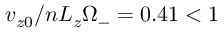Convert formula to latex. <formula><loc_0><loc_0><loc_500><loc_500>v _ { z 0 } / n L _ { z } \Omega _ { - } = 0 . 4 1 < 1</formula> 